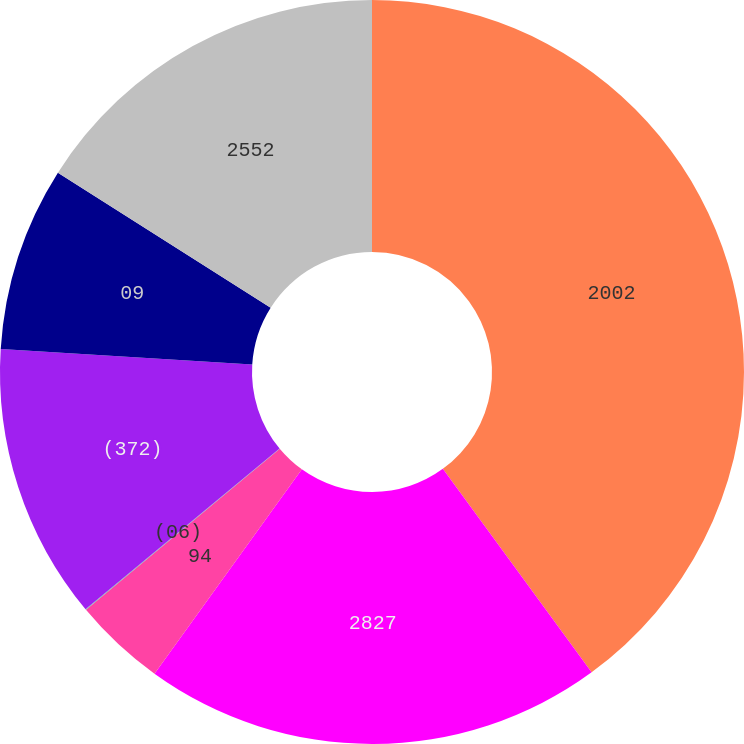<chart> <loc_0><loc_0><loc_500><loc_500><pie_chart><fcel>2002<fcel>2827<fcel>94<fcel>(06)<fcel>(372)<fcel>09<fcel>2552<nl><fcel>39.95%<fcel>19.99%<fcel>4.02%<fcel>0.03%<fcel>12.0%<fcel>8.01%<fcel>16.0%<nl></chart> 